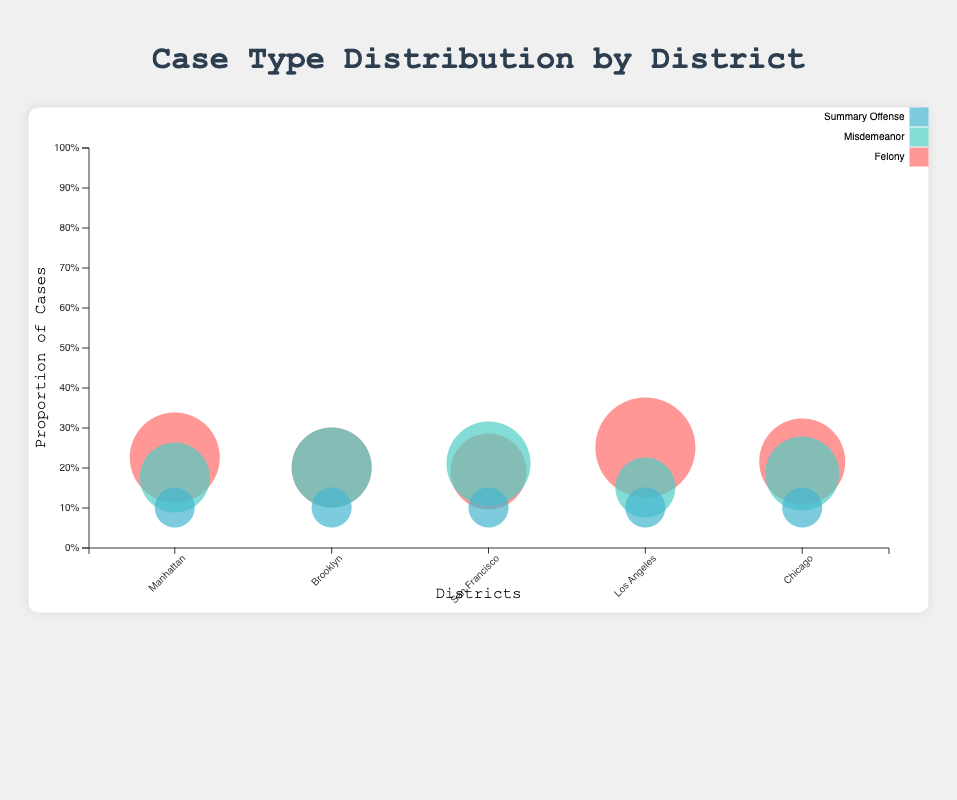What is the proportion of felony cases in Manhattan? By examining the Manattan bubble representing felony cases, we see it is categorized with a proportion of 0.45.
Answer: 0.45 Which district has the highest proportion of felony cases? Comparing the proportions, Los Angeles has the highest proportion of felony cases with 0.50.
Answer: Los Angeles What is the total proportion of misdemeanor and summary offense cases in San Francisco? The proportion for misdemeanor cases is 0.42 and for summary offenses is 0.20. Adding these gives 0.42 + 0.20 = 0.62.
Answer: 0.62 How does the proportion of felony cases compare between Brooklyn and Chicago? Brooklyn has a proportion of 0.40 for felony cases, while Chicago has a higher proportion of 0.43.
Answer: Chicago has a higher proportion Which district shows the most varied proportions among the three case types? Looking at the size of the bubbles, Brooklyn has equal proportions of 0.40 for felony and misdemeanor cases and 0.20 for summary offenses, indicating minimal variation. Los Angeles, for example, has more varied proportions of 0.50, 0.30, and 0.20.
Answer: Los Angeles Is there a district where the proportion of misdemeanor cases is larger than felony cases? Examining the bubble sizes, San Francisco has a larger proportion of misdemeanor cases (0.42) compared to felony cases (0.38).
Answer: San Francisco What is the combined proportion of summary offense cases across all districts? Each district has a summary offense proportion of 0.20. Summing these across five districts gives 0.20 * 5 = 1.00.
Answer: 1.00 Which case type has the smallest combined proportion across all districts? Examining the bubbles, summary offense cases have the smallest individual proportions of 0.20 in each district. Summing proportions for felony and misdemeanor cases in all districts yields larger numbers.
Answer: Summary Offense 